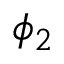Convert formula to latex. <formula><loc_0><loc_0><loc_500><loc_500>\phi _ { 2 }</formula> 